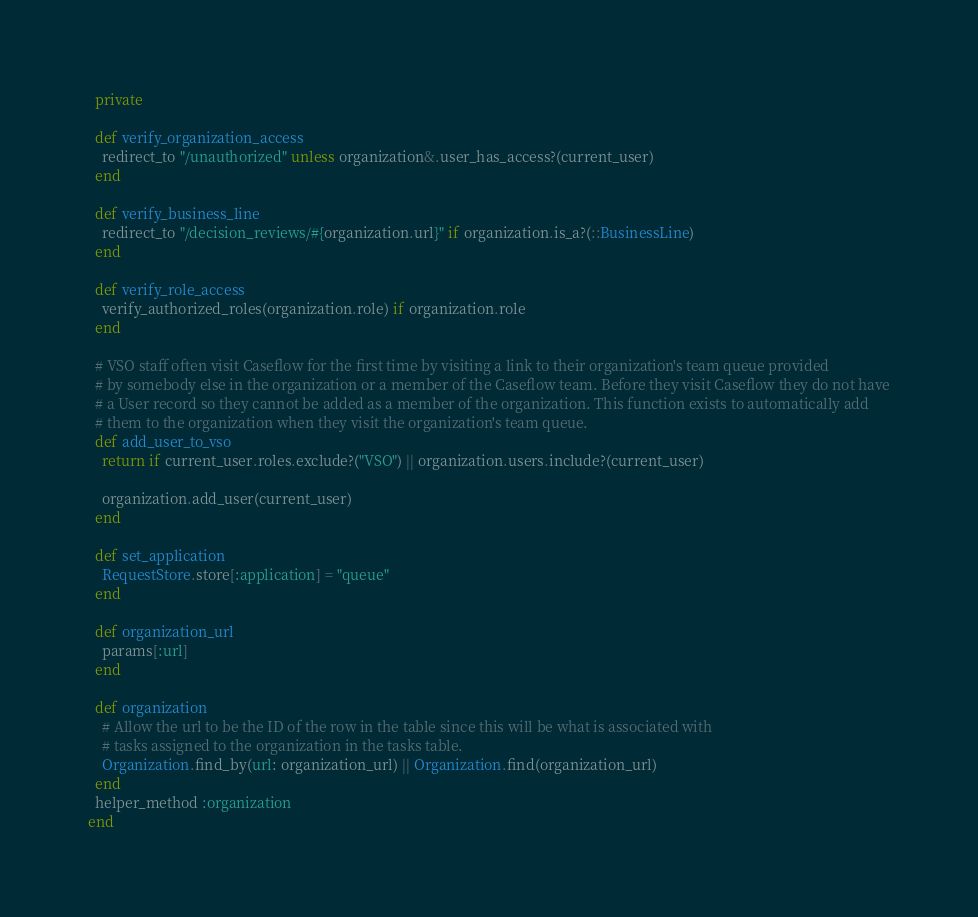<code> <loc_0><loc_0><loc_500><loc_500><_Ruby_>  private

  def verify_organization_access
    redirect_to "/unauthorized" unless organization&.user_has_access?(current_user)
  end

  def verify_business_line
    redirect_to "/decision_reviews/#{organization.url}" if organization.is_a?(::BusinessLine)
  end

  def verify_role_access
    verify_authorized_roles(organization.role) if organization.role
  end

  # VSO staff often visit Caseflow for the first time by visiting a link to their organization's team queue provided
  # by somebody else in the organization or a member of the Caseflow team. Before they visit Caseflow they do not have
  # a User record so they cannot be added as a member of the organization. This function exists to automatically add
  # them to the organization when they visit the organization's team queue.
  def add_user_to_vso
    return if current_user.roles.exclude?("VSO") || organization.users.include?(current_user)

    organization.add_user(current_user)
  end

  def set_application
    RequestStore.store[:application] = "queue"
  end

  def organization_url
    params[:url]
  end

  def organization
    # Allow the url to be the ID of the row in the table since this will be what is associated with
    # tasks assigned to the organization in the tasks table.
    Organization.find_by(url: organization_url) || Organization.find(organization_url)
  end
  helper_method :organization
end
</code> 